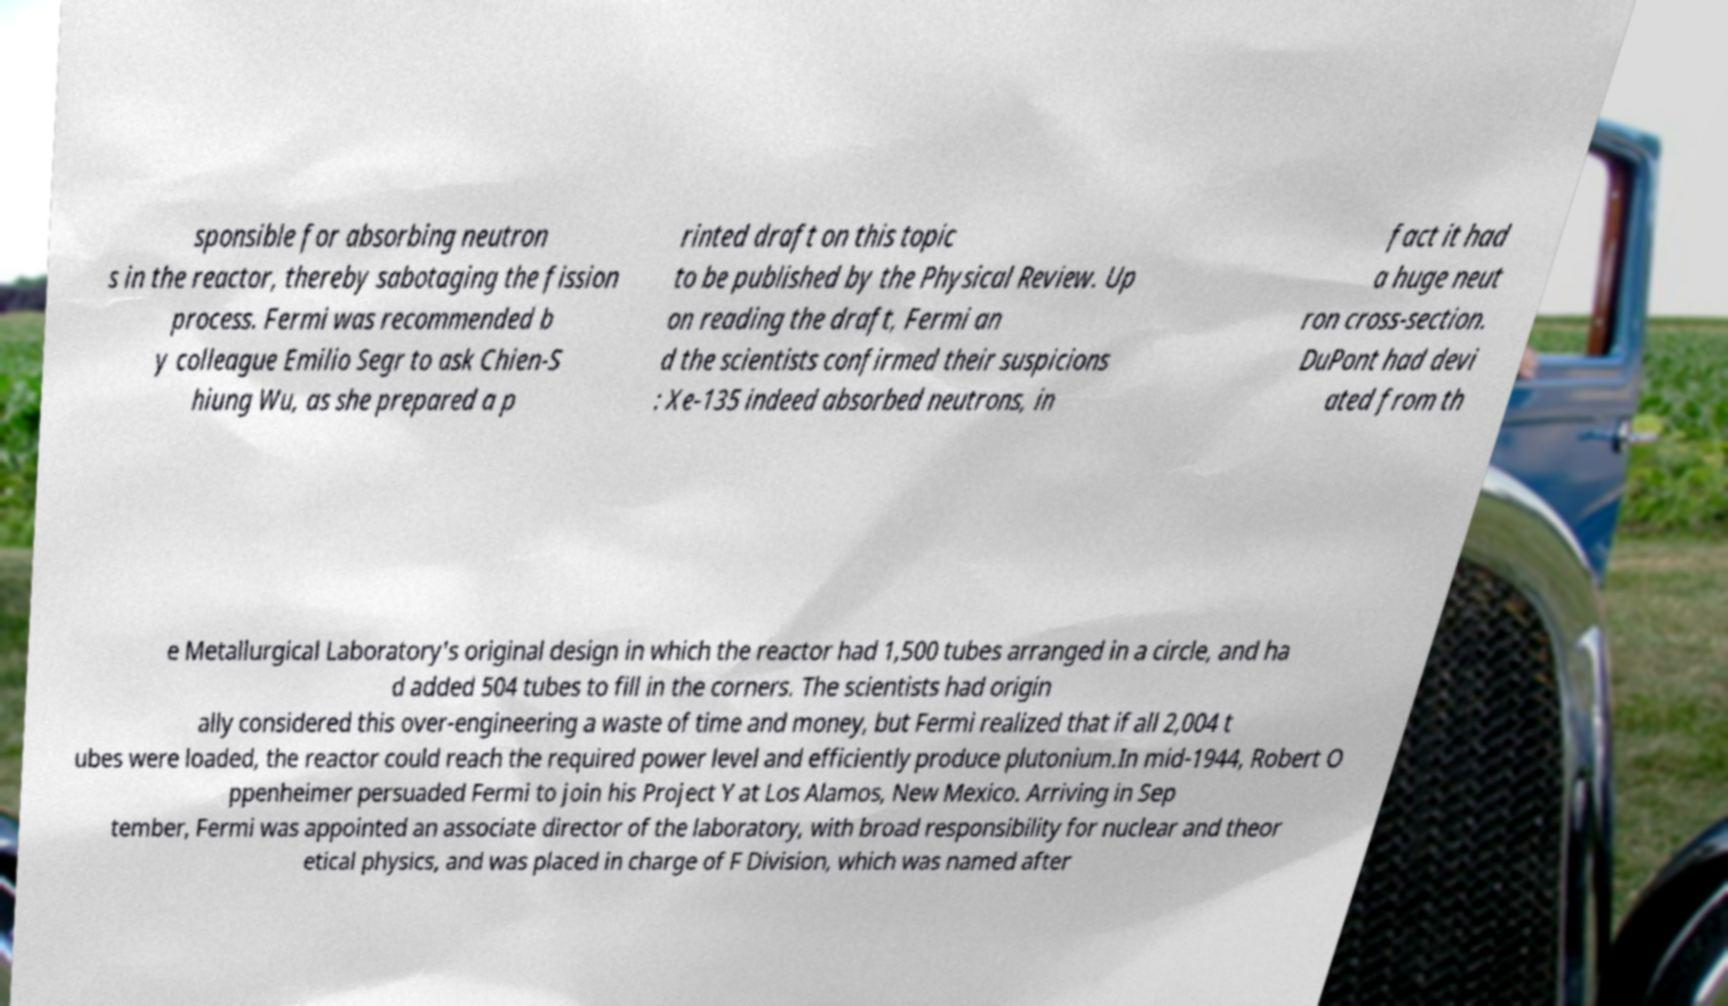For documentation purposes, I need the text within this image transcribed. Could you provide that? sponsible for absorbing neutron s in the reactor, thereby sabotaging the fission process. Fermi was recommended b y colleague Emilio Segr to ask Chien-S hiung Wu, as she prepared a p rinted draft on this topic to be published by the Physical Review. Up on reading the draft, Fermi an d the scientists confirmed their suspicions : Xe-135 indeed absorbed neutrons, in fact it had a huge neut ron cross-section. DuPont had devi ated from th e Metallurgical Laboratory's original design in which the reactor had 1,500 tubes arranged in a circle, and ha d added 504 tubes to fill in the corners. The scientists had origin ally considered this over-engineering a waste of time and money, but Fermi realized that if all 2,004 t ubes were loaded, the reactor could reach the required power level and efficiently produce plutonium.In mid-1944, Robert O ppenheimer persuaded Fermi to join his Project Y at Los Alamos, New Mexico. Arriving in Sep tember, Fermi was appointed an associate director of the laboratory, with broad responsibility for nuclear and theor etical physics, and was placed in charge of F Division, which was named after 